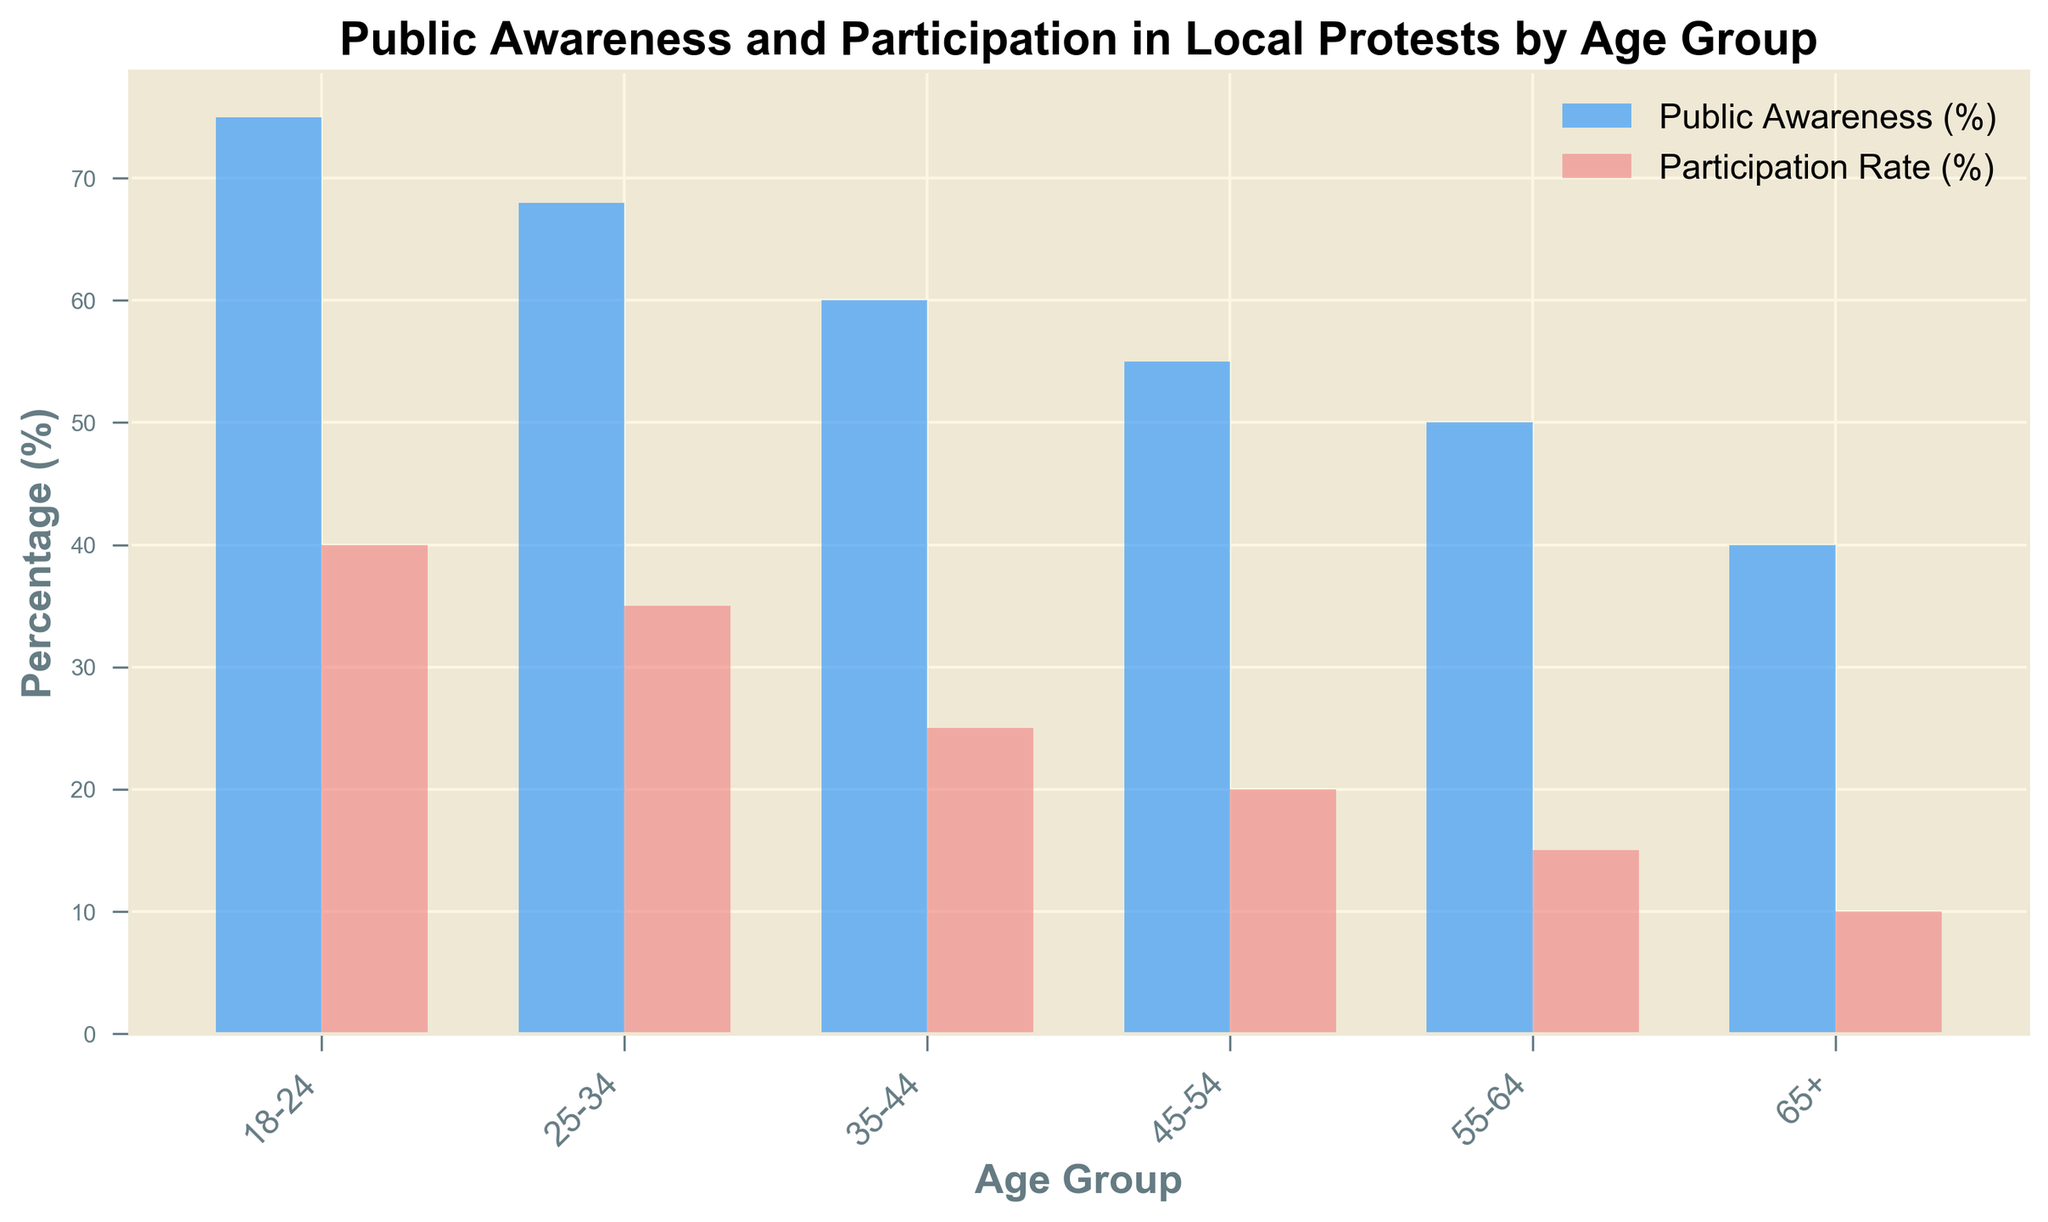What is the age group with the highest public awareness of local protests? The bar chart shows two sets of bars for each age group. The tallest blue bar represents the age group with the highest public awareness.
Answer: 18-24 By how much does the public awareness percentage decrease from the 18-24 age group to the 65+ age group? Subtract the public awareness percentage of the 65+ age group (40) from the public awareness percentage of the 18-24 age group (75).
Answer: 35 Which age group has a higher participation rate, the 35-44 group or the 55-64 group? Compare the heights of the red bars for each group. The red bar for the 35-44 age group is taller than the red bar for the 55-64 age group.
Answer: 35-44 Is there any age group where both public awareness and participation rates exceed 60%? Check the blue and red bars for each age group to see if both bars exceed 60%. No age group meets this criterion.
Answer: No Which age group has the smallest difference between public awareness and participation rate? Calculate the difference between the blue and red bars for each age group. The smallest difference is observed for the 65+ age group (40 - 10 = 30).
Answer: 65+ What is the average public awareness percentage across all age groups? Add all public awareness percentages (75 + 68 + 60 + 55 + 50 + 40) and then divide by the number of age groups (6).
Answer: 58 How does the participation rate in local protests compare between the 18-24 age group and the 45-54 age group? Compare the heights of the red bars for the 18-24 age group and the 45-54 age group. The 18-24 age group has a much higher participation rate (40% vs. 20%).
Answer: Higher in 18-24 Which color represents the public awareness percentage in the bar chart? Identify the color of the bar that corresponds to the public awareness category. The public awareness percentage is represented by the blue bars.
Answer: Blue What is the combined total of participation rates for the 18-24 and 25-34 age groups? Add the participation rates of 18-24 (40%) and 25-34 (35%) age groups.
Answer: 75 